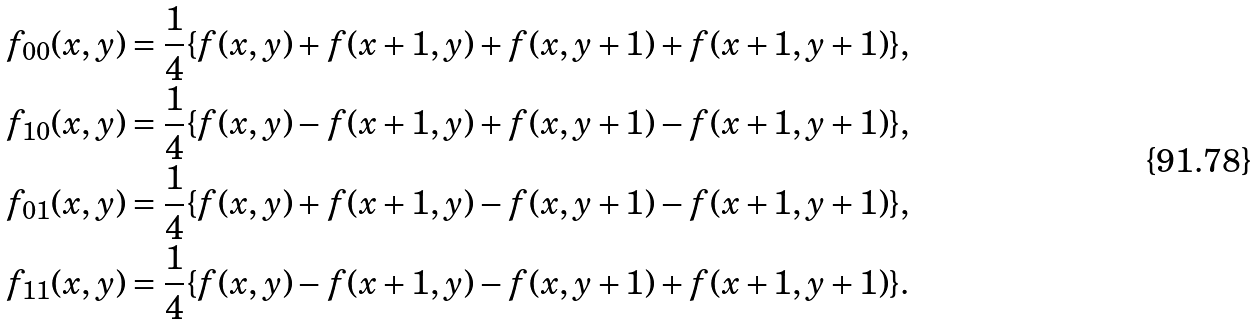Convert formula to latex. <formula><loc_0><loc_0><loc_500><loc_500>f _ { 0 0 } ( x , y ) = \frac { 1 } { 4 } \{ f ( x , y ) + f ( x + 1 , y ) + f ( x , y + 1 ) + f ( x + 1 , y + 1 ) \} , \\ f _ { 1 0 } ( x , y ) = \frac { 1 } { 4 } \{ f ( x , y ) - f ( x + 1 , y ) + f ( x , y + 1 ) - f ( x + 1 , y + 1 ) \} , \\ f _ { 0 1 } ( x , y ) = \frac { 1 } { 4 } \{ f ( x , y ) + f ( x + 1 , y ) - f ( x , y + 1 ) - f ( x + 1 , y + 1 ) \} , \\ f _ { 1 1 } ( x , y ) = \frac { 1 } { 4 } \{ f ( x , y ) - f ( x + 1 , y ) - f ( x , y + 1 ) + f ( x + 1 , y + 1 ) \} .</formula> 